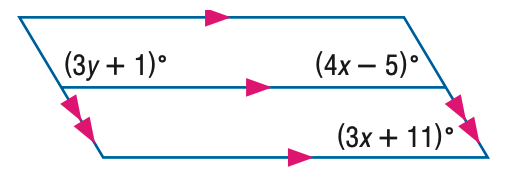Question: Find y in the figure.
Choices:
A. 30
B. 35
C. 40
D. 45
Answer with the letter. Answer: C 